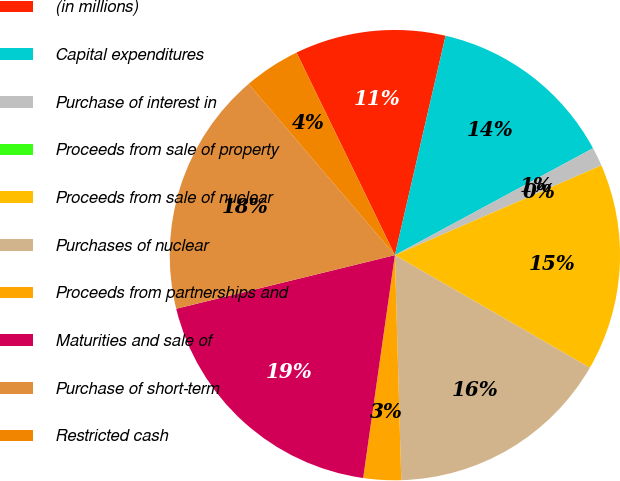<chart> <loc_0><loc_0><loc_500><loc_500><pie_chart><fcel>(in millions)<fcel>Capital expenditures<fcel>Purchase of interest in<fcel>Proceeds from sale of property<fcel>Proceeds from sale of nuclear<fcel>Purchases of nuclear<fcel>Proceeds from partnerships and<fcel>Maturities and sale of<fcel>Purchase of short-term<fcel>Restricted cash<nl><fcel>10.81%<fcel>13.51%<fcel>1.35%<fcel>0.0%<fcel>14.86%<fcel>16.21%<fcel>2.7%<fcel>18.92%<fcel>17.57%<fcel>4.06%<nl></chart> 